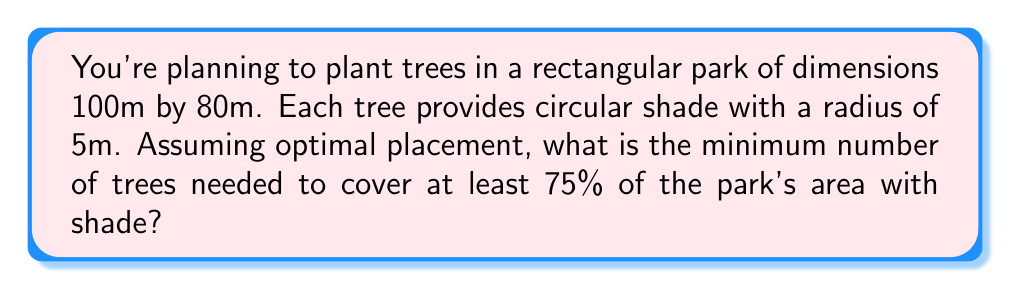Help me with this question. To solve this problem, we need to follow these steps:

1. Calculate the total area of the park:
   $A_{park} = 100m \times 80m = 8000m^2$

2. Calculate the target shaded area (75% of the park):
   $A_{target} = 0.75 \times 8000m^2 = 6000m^2$

3. Calculate the area of shade provided by one tree:
   $A_{tree} = \pi r^2 = \pi \times (5m)^2 = 25\pi m^2 \approx 78.54m^2$

4. To maximize efficiency, we need to arrange the trees in a hexagonal pattern. In this arrangement, each tree's shade circle overlaps slightly with its neighbors, forming a tessellation. The efficiency of this arrangement is approximately 90.7% of the total area of the circles.

5. Calculate the effective shade area per tree:
   $A_{effective} = 0.907 \times 78.54m^2 \approx 71.24m^2$

6. Calculate the number of trees needed:
   $N_{trees} = \frac{A_{target}}{A_{effective}} = \frac{6000m^2}{71.24m^2} \approx 84.22$

7. Since we can't plant a fractional tree, we round up to the nearest whole number.

[asy]
size(200);
fill(box((0,0),(100,80)),gray(0.9));
for(int i=0; i<=100; i+=10)
  for(int j=0; j<=80; j+=8.66)
    fill(circle((i+(j%17.32==0?0:5),j),5),gray(0.7));
draw(box((0,0),(100,80)));
label("100m",(50,-5),S);
label("80m",(-5,40),W);
[/asy]

The diagram above illustrates the hexagonal arrangement of trees (not to scale and not showing all 85 trees for clarity).
Answer: 85 trees 